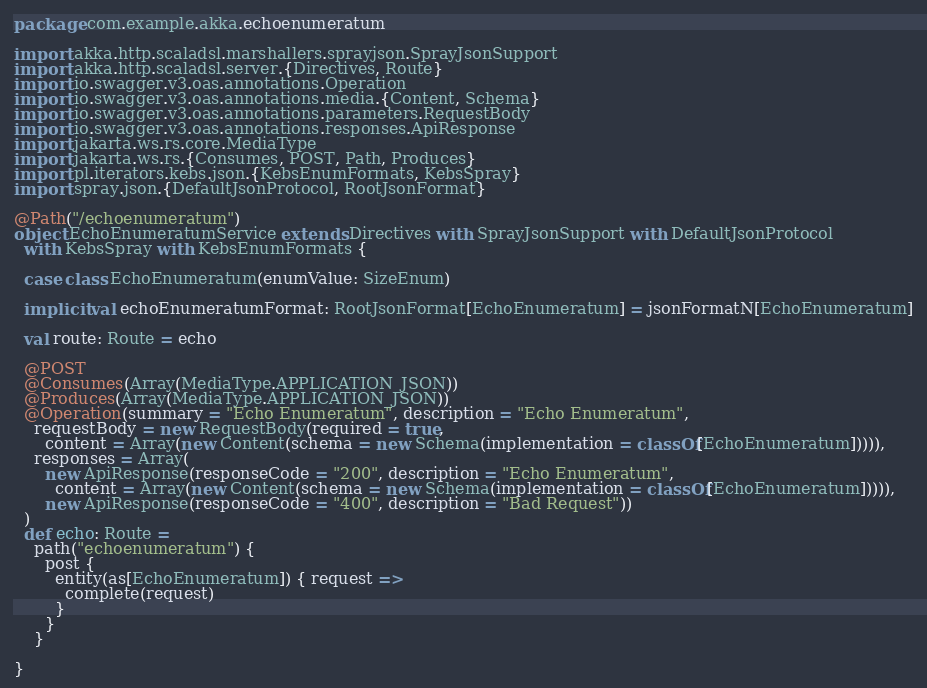Convert code to text. <code><loc_0><loc_0><loc_500><loc_500><_Scala_>package com.example.akka.echoenumeratum

import akka.http.scaladsl.marshallers.sprayjson.SprayJsonSupport
import akka.http.scaladsl.server.{Directives, Route}
import io.swagger.v3.oas.annotations.Operation
import io.swagger.v3.oas.annotations.media.{Content, Schema}
import io.swagger.v3.oas.annotations.parameters.RequestBody
import io.swagger.v3.oas.annotations.responses.ApiResponse
import jakarta.ws.rs.core.MediaType
import jakarta.ws.rs.{Consumes, POST, Path, Produces}
import pl.iterators.kebs.json.{KebsEnumFormats, KebsSpray}
import spray.json.{DefaultJsonProtocol, RootJsonFormat}

@Path("/echoenumeratum")
object EchoEnumeratumService extends Directives with SprayJsonSupport with DefaultJsonProtocol
  with KebsSpray with KebsEnumFormats {

  case class EchoEnumeratum(enumValue: SizeEnum)

  implicit val echoEnumeratumFormat: RootJsonFormat[EchoEnumeratum] = jsonFormatN[EchoEnumeratum]

  val route: Route = echo

  @POST
  @Consumes(Array(MediaType.APPLICATION_JSON))
  @Produces(Array(MediaType.APPLICATION_JSON))
  @Operation(summary = "Echo Enumeratum", description = "Echo Enumeratum",
    requestBody = new RequestBody(required = true,
      content = Array(new Content(schema = new Schema(implementation = classOf[EchoEnumeratum])))),
    responses = Array(
      new ApiResponse(responseCode = "200", description = "Echo Enumeratum",
        content = Array(new Content(schema = new Schema(implementation = classOf[EchoEnumeratum])))),
      new ApiResponse(responseCode = "400", description = "Bad Request"))
  )
  def echo: Route =
    path("echoenumeratum") {
      post {
        entity(as[EchoEnumeratum]) { request =>
          complete(request)
        }
      }
    }

}
</code> 